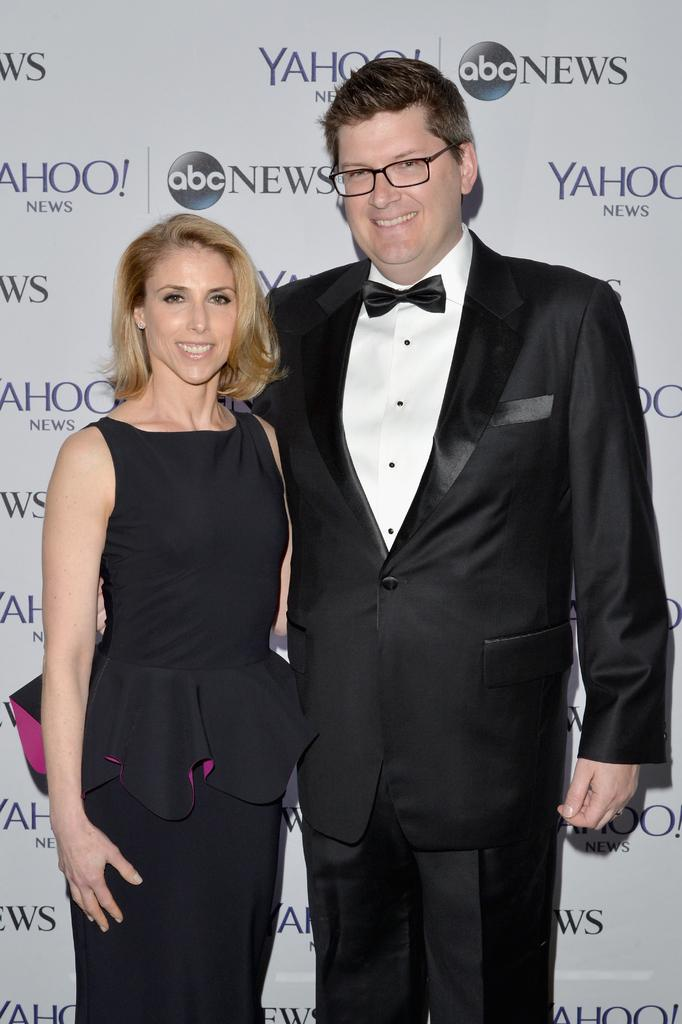<image>
Share a concise interpretation of the image provided. The logo with the letters abc in a black circle. 